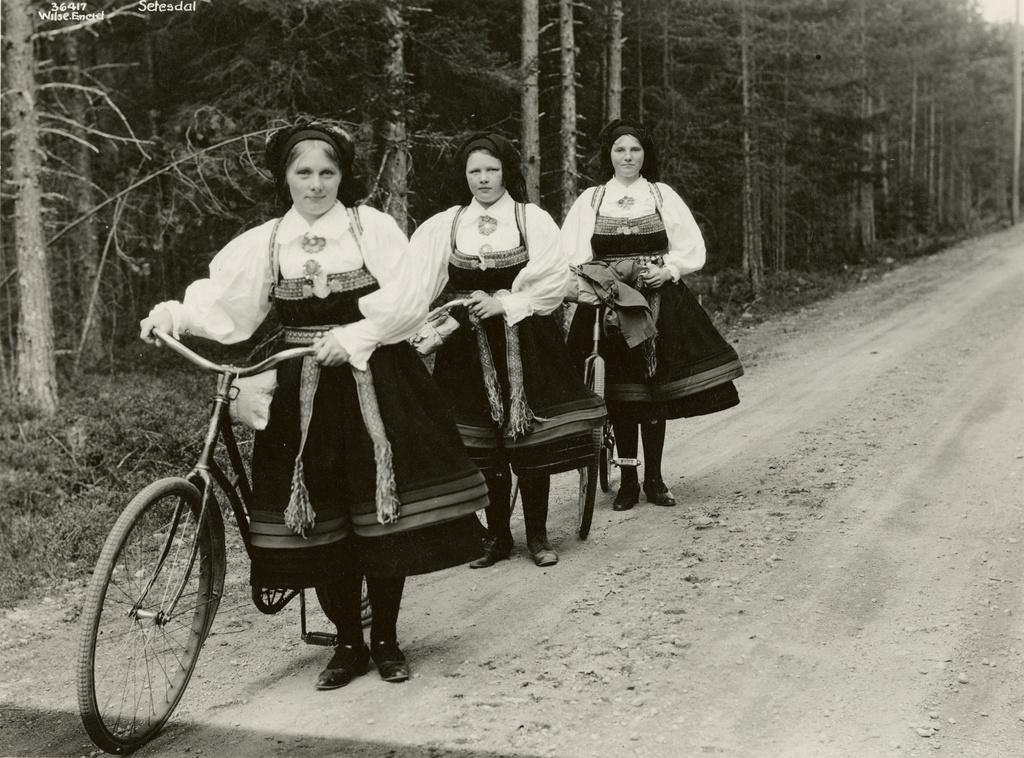What is the color scheme of the image? The image is black and white. What type of natural elements can be seen in the image? There are trees in the image. How many women are present in the image? There are three women in the image. What are the women doing in the image? The women are standing near bicycles. What are the women wearing in the image? The women are wearing the same attire. What type of lizards can be seen climbing the trees in the image? There are no lizards present in the image; it features trees, women, and bicycles. What is the smell of the flowers in the image? There are no flowers present in the image, so it is not possible to determine their smell. 